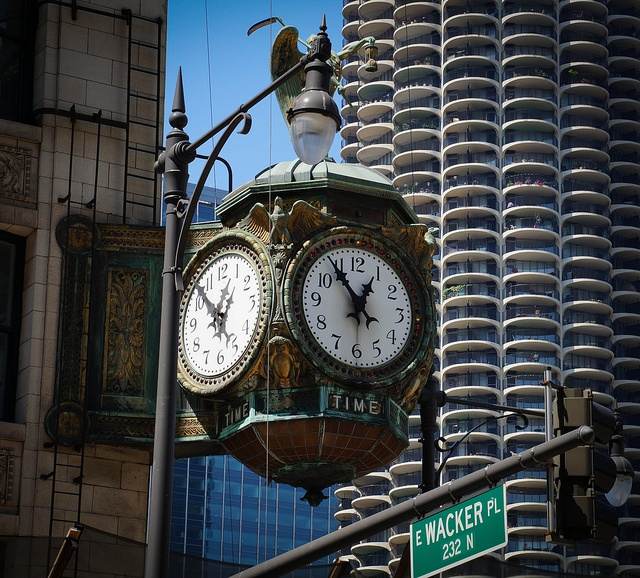Describe the objects in this image and their specific colors. I can see clock in black, white, darkgray, and gray tones, clock in black, darkgray, and gray tones, and traffic light in black and gray tones in this image. 